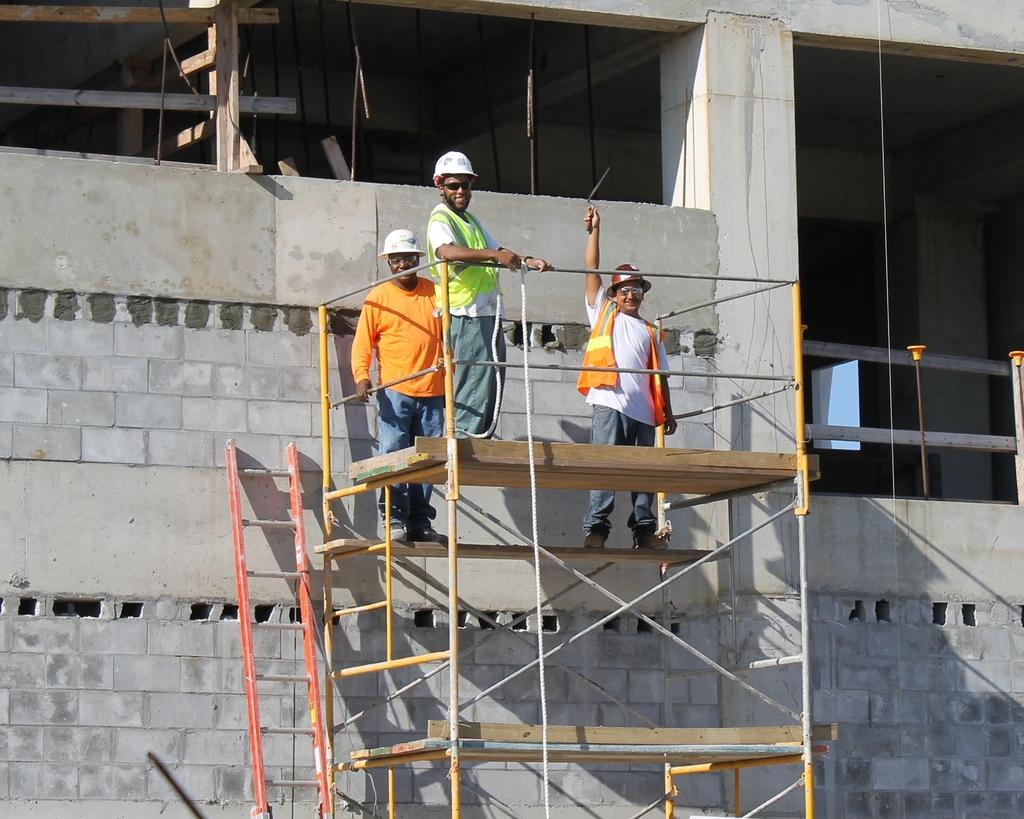How many people are present in the image? There are three people standing in the image. Can you describe the background of the image? There is a building in the background of the image. What type of blood is visible on the trucks in the image? There are no trucks or blood present in the image; it features three people and a building in the background. 